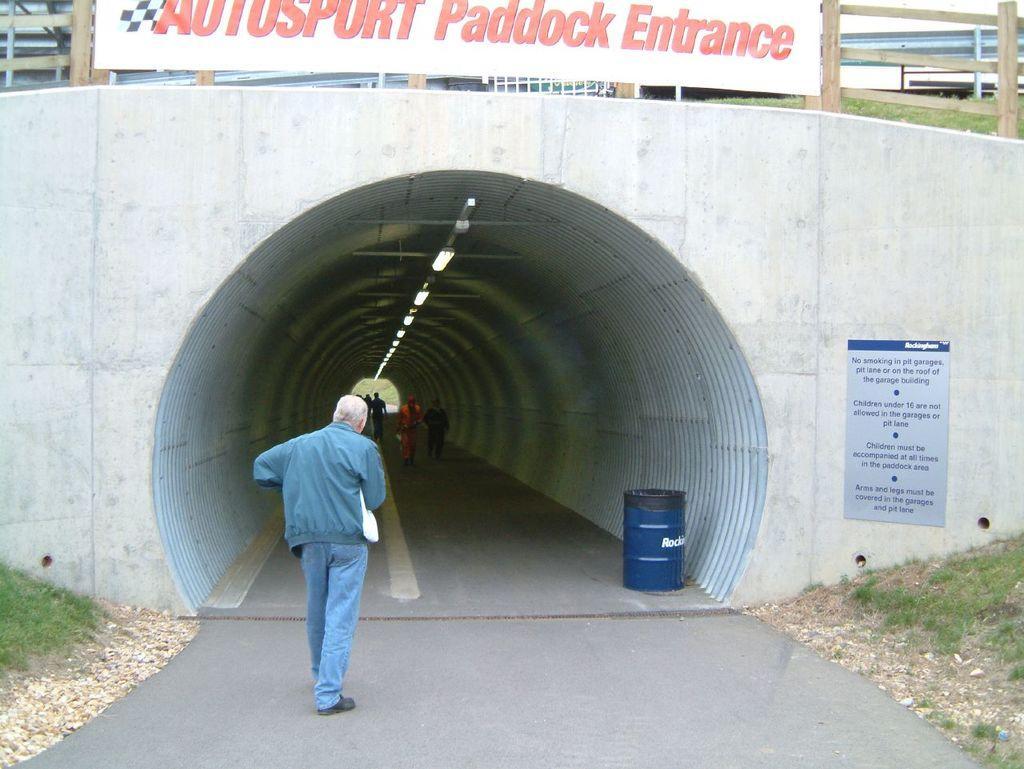How would you summarize this image in a sentence or two? In this picture, we can see a man is walking on the road and on the right side of the man there are stones, grass and blue steel barrel. In front of the man there are groups of people walking in the tunnel. On top of the tunnel there is a banner and a wooden fence. 